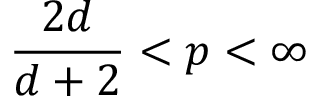Convert formula to latex. <formula><loc_0><loc_0><loc_500><loc_500>\frac { 2 d } { d + 2 } < p < \infty</formula> 